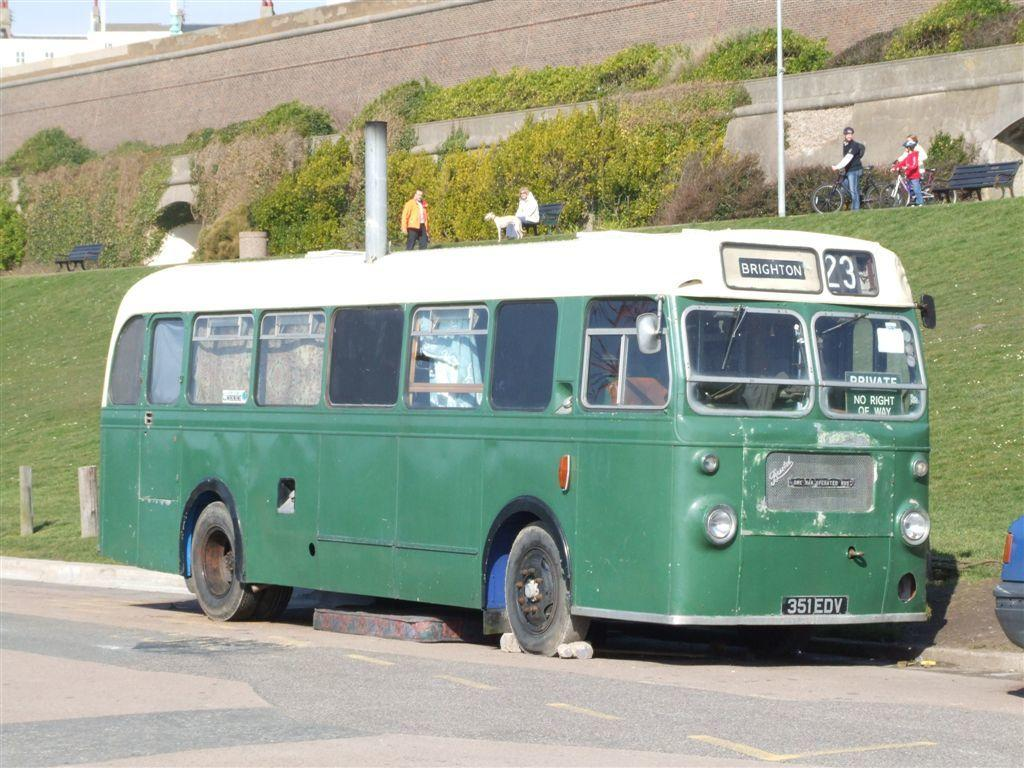<image>
Relay a brief, clear account of the picture shown. a bus that had the number 23 on the front of it 